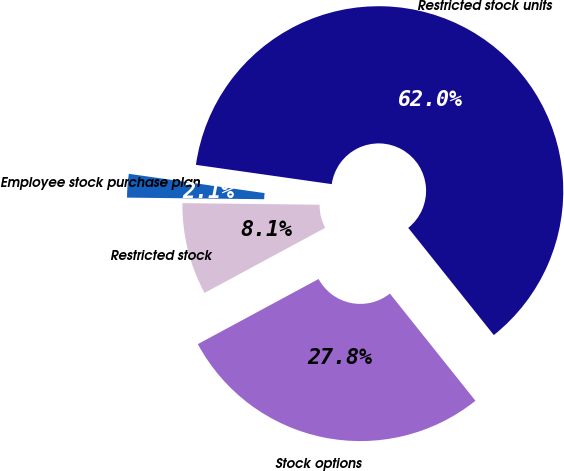<chart> <loc_0><loc_0><loc_500><loc_500><pie_chart><fcel>Restricted stock units<fcel>Stock options<fcel>Restricted stock<fcel>Employee stock purchase plan<nl><fcel>62.04%<fcel>27.85%<fcel>8.06%<fcel>2.06%<nl></chart> 